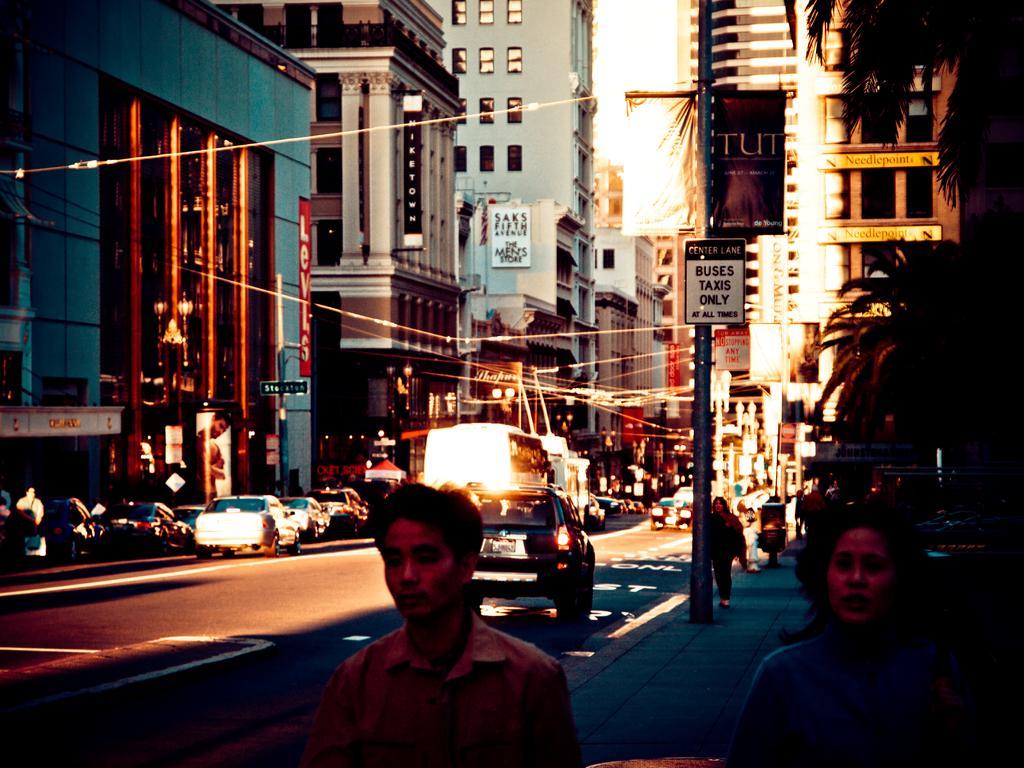Describe this image in one or two sentences. This is clicked in the street, there are vehicles going on the road and few walking on the footpath in the front, there are buildings on either side of the road and above its sky. 